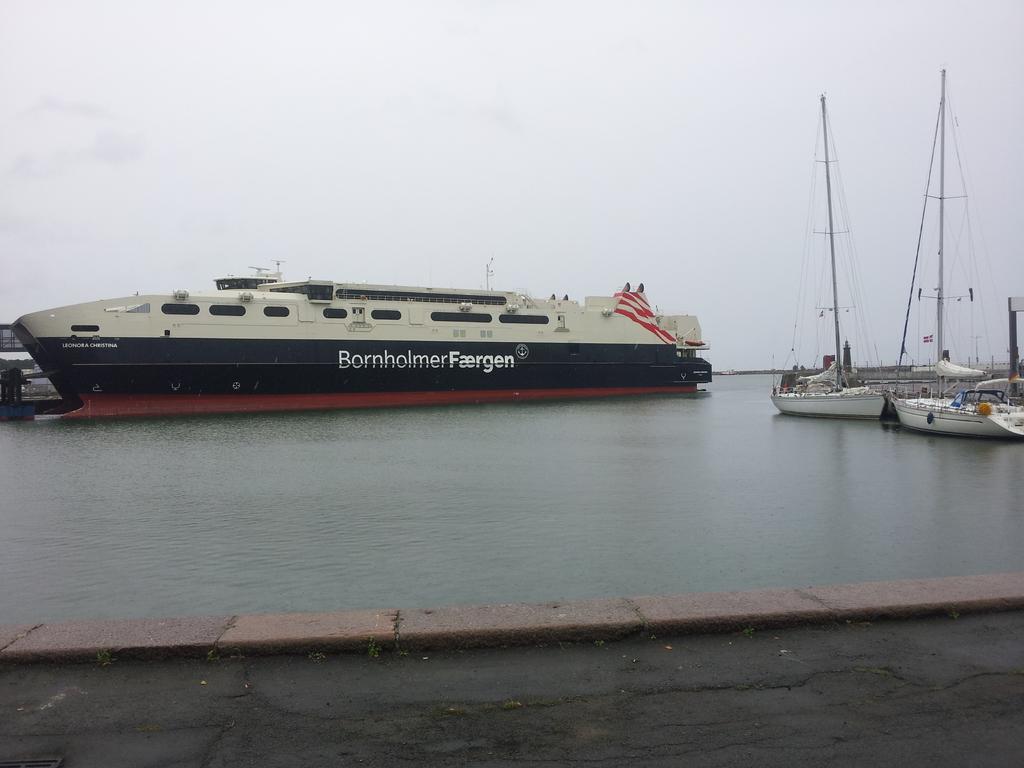What is the name of the ship?
Give a very brief answer. Bornholmer faergen. What is the first letter of the name?
Provide a succinct answer. B. 